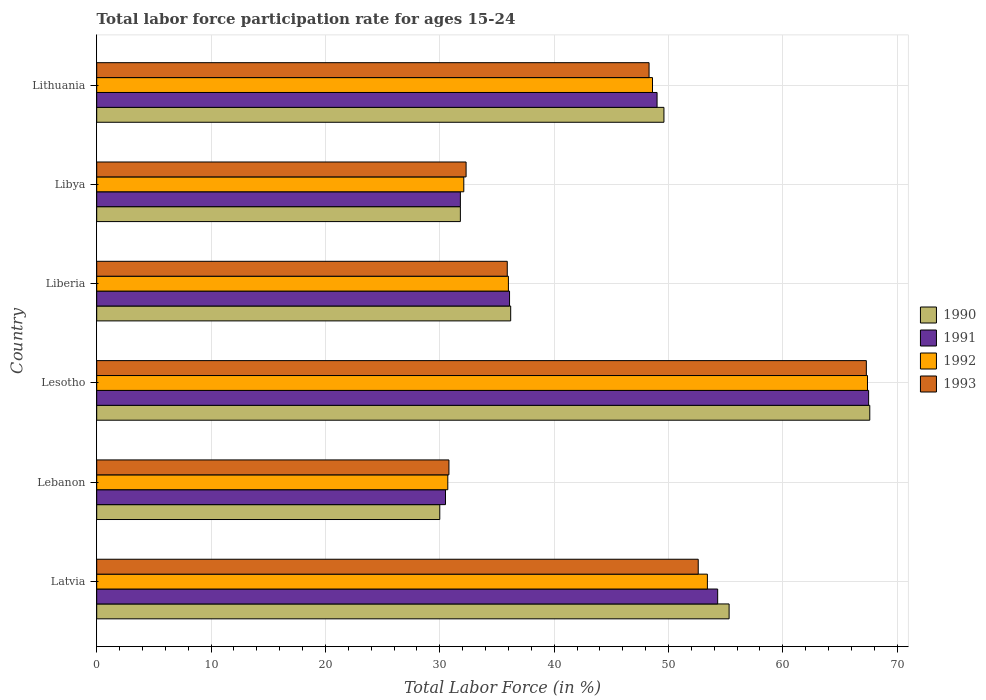How many different coloured bars are there?
Your answer should be compact. 4. How many groups of bars are there?
Ensure brevity in your answer.  6. Are the number of bars per tick equal to the number of legend labels?
Ensure brevity in your answer.  Yes. How many bars are there on the 3rd tick from the top?
Offer a terse response. 4. How many bars are there on the 6th tick from the bottom?
Your answer should be very brief. 4. What is the label of the 2nd group of bars from the top?
Ensure brevity in your answer.  Libya. What is the labor force participation rate in 1990 in Liberia?
Provide a succinct answer. 36.2. Across all countries, what is the maximum labor force participation rate in 1993?
Provide a short and direct response. 67.3. Across all countries, what is the minimum labor force participation rate in 1990?
Provide a short and direct response. 30. In which country was the labor force participation rate in 1991 maximum?
Make the answer very short. Lesotho. In which country was the labor force participation rate in 1990 minimum?
Your answer should be very brief. Lebanon. What is the total labor force participation rate in 1992 in the graph?
Provide a short and direct response. 268.2. What is the difference between the labor force participation rate in 1993 in Lebanon and that in Lesotho?
Ensure brevity in your answer.  -36.5. What is the difference between the labor force participation rate in 1992 in Lesotho and the labor force participation rate in 1993 in Lithuania?
Provide a succinct answer. 19.1. What is the average labor force participation rate in 1990 per country?
Your answer should be compact. 45.08. What is the difference between the labor force participation rate in 1991 and labor force participation rate in 1992 in Lebanon?
Your response must be concise. -0.2. In how many countries, is the labor force participation rate in 1990 greater than 68 %?
Keep it short and to the point. 0. What is the ratio of the labor force participation rate in 1992 in Latvia to that in Liberia?
Your answer should be compact. 1.48. Is the labor force participation rate in 1993 in Latvia less than that in Lebanon?
Your answer should be compact. No. Is the difference between the labor force participation rate in 1991 in Latvia and Liberia greater than the difference between the labor force participation rate in 1992 in Latvia and Liberia?
Your answer should be very brief. Yes. What is the difference between the highest and the second highest labor force participation rate in 1992?
Offer a terse response. 14. What is the difference between the highest and the lowest labor force participation rate in 1990?
Provide a short and direct response. 37.6. Is the sum of the labor force participation rate in 1992 in Latvia and Libya greater than the maximum labor force participation rate in 1990 across all countries?
Ensure brevity in your answer.  Yes. Is it the case that in every country, the sum of the labor force participation rate in 1992 and labor force participation rate in 1991 is greater than the sum of labor force participation rate in 1993 and labor force participation rate in 1990?
Your response must be concise. No. What does the 4th bar from the top in Latvia represents?
Your response must be concise. 1990. What does the 2nd bar from the bottom in Libya represents?
Keep it short and to the point. 1991. Are all the bars in the graph horizontal?
Provide a short and direct response. Yes. What is the difference between two consecutive major ticks on the X-axis?
Your answer should be compact. 10. Are the values on the major ticks of X-axis written in scientific E-notation?
Ensure brevity in your answer.  No. How many legend labels are there?
Ensure brevity in your answer.  4. What is the title of the graph?
Provide a short and direct response. Total labor force participation rate for ages 15-24. Does "1979" appear as one of the legend labels in the graph?
Your answer should be very brief. No. What is the label or title of the Y-axis?
Your response must be concise. Country. What is the Total Labor Force (in %) in 1990 in Latvia?
Offer a terse response. 55.3. What is the Total Labor Force (in %) of 1991 in Latvia?
Your answer should be very brief. 54.3. What is the Total Labor Force (in %) in 1992 in Latvia?
Offer a very short reply. 53.4. What is the Total Labor Force (in %) of 1993 in Latvia?
Your response must be concise. 52.6. What is the Total Labor Force (in %) of 1991 in Lebanon?
Offer a very short reply. 30.5. What is the Total Labor Force (in %) of 1992 in Lebanon?
Offer a terse response. 30.7. What is the Total Labor Force (in %) in 1993 in Lebanon?
Keep it short and to the point. 30.8. What is the Total Labor Force (in %) in 1990 in Lesotho?
Keep it short and to the point. 67.6. What is the Total Labor Force (in %) in 1991 in Lesotho?
Offer a very short reply. 67.5. What is the Total Labor Force (in %) in 1992 in Lesotho?
Make the answer very short. 67.4. What is the Total Labor Force (in %) of 1993 in Lesotho?
Your answer should be compact. 67.3. What is the Total Labor Force (in %) in 1990 in Liberia?
Your answer should be compact. 36.2. What is the Total Labor Force (in %) in 1991 in Liberia?
Give a very brief answer. 36.1. What is the Total Labor Force (in %) of 1992 in Liberia?
Offer a very short reply. 36. What is the Total Labor Force (in %) of 1993 in Liberia?
Give a very brief answer. 35.9. What is the Total Labor Force (in %) in 1990 in Libya?
Offer a very short reply. 31.8. What is the Total Labor Force (in %) in 1991 in Libya?
Provide a succinct answer. 31.8. What is the Total Labor Force (in %) of 1992 in Libya?
Your answer should be very brief. 32.1. What is the Total Labor Force (in %) in 1993 in Libya?
Offer a very short reply. 32.3. What is the Total Labor Force (in %) in 1990 in Lithuania?
Make the answer very short. 49.6. What is the Total Labor Force (in %) in 1991 in Lithuania?
Provide a short and direct response. 49. What is the Total Labor Force (in %) in 1992 in Lithuania?
Your answer should be very brief. 48.6. What is the Total Labor Force (in %) of 1993 in Lithuania?
Your answer should be very brief. 48.3. Across all countries, what is the maximum Total Labor Force (in %) in 1990?
Provide a succinct answer. 67.6. Across all countries, what is the maximum Total Labor Force (in %) of 1991?
Your answer should be very brief. 67.5. Across all countries, what is the maximum Total Labor Force (in %) in 1992?
Ensure brevity in your answer.  67.4. Across all countries, what is the maximum Total Labor Force (in %) of 1993?
Offer a very short reply. 67.3. Across all countries, what is the minimum Total Labor Force (in %) in 1991?
Provide a short and direct response. 30.5. Across all countries, what is the minimum Total Labor Force (in %) in 1992?
Provide a succinct answer. 30.7. Across all countries, what is the minimum Total Labor Force (in %) in 1993?
Provide a succinct answer. 30.8. What is the total Total Labor Force (in %) of 1990 in the graph?
Offer a very short reply. 270.5. What is the total Total Labor Force (in %) of 1991 in the graph?
Keep it short and to the point. 269.2. What is the total Total Labor Force (in %) in 1992 in the graph?
Your response must be concise. 268.2. What is the total Total Labor Force (in %) of 1993 in the graph?
Ensure brevity in your answer.  267.2. What is the difference between the Total Labor Force (in %) of 1990 in Latvia and that in Lebanon?
Provide a short and direct response. 25.3. What is the difference between the Total Labor Force (in %) in 1991 in Latvia and that in Lebanon?
Give a very brief answer. 23.8. What is the difference between the Total Labor Force (in %) of 1992 in Latvia and that in Lebanon?
Provide a short and direct response. 22.7. What is the difference between the Total Labor Force (in %) in 1993 in Latvia and that in Lebanon?
Provide a short and direct response. 21.8. What is the difference between the Total Labor Force (in %) in 1990 in Latvia and that in Lesotho?
Your answer should be compact. -12.3. What is the difference between the Total Labor Force (in %) in 1992 in Latvia and that in Lesotho?
Make the answer very short. -14. What is the difference between the Total Labor Force (in %) of 1993 in Latvia and that in Lesotho?
Your response must be concise. -14.7. What is the difference between the Total Labor Force (in %) of 1992 in Latvia and that in Liberia?
Offer a very short reply. 17.4. What is the difference between the Total Labor Force (in %) in 1993 in Latvia and that in Liberia?
Provide a succinct answer. 16.7. What is the difference between the Total Labor Force (in %) in 1990 in Latvia and that in Libya?
Keep it short and to the point. 23.5. What is the difference between the Total Labor Force (in %) in 1992 in Latvia and that in Libya?
Keep it short and to the point. 21.3. What is the difference between the Total Labor Force (in %) in 1993 in Latvia and that in Libya?
Keep it short and to the point. 20.3. What is the difference between the Total Labor Force (in %) in 1993 in Latvia and that in Lithuania?
Your answer should be very brief. 4.3. What is the difference between the Total Labor Force (in %) of 1990 in Lebanon and that in Lesotho?
Offer a very short reply. -37.6. What is the difference between the Total Labor Force (in %) of 1991 in Lebanon and that in Lesotho?
Keep it short and to the point. -37. What is the difference between the Total Labor Force (in %) of 1992 in Lebanon and that in Lesotho?
Your answer should be very brief. -36.7. What is the difference between the Total Labor Force (in %) of 1993 in Lebanon and that in Lesotho?
Provide a succinct answer. -36.5. What is the difference between the Total Labor Force (in %) of 1990 in Lebanon and that in Liberia?
Offer a terse response. -6.2. What is the difference between the Total Labor Force (in %) of 1993 in Lebanon and that in Liberia?
Your response must be concise. -5.1. What is the difference between the Total Labor Force (in %) of 1992 in Lebanon and that in Libya?
Provide a short and direct response. -1.4. What is the difference between the Total Labor Force (in %) of 1993 in Lebanon and that in Libya?
Your answer should be very brief. -1.5. What is the difference between the Total Labor Force (in %) in 1990 in Lebanon and that in Lithuania?
Offer a terse response. -19.6. What is the difference between the Total Labor Force (in %) of 1991 in Lebanon and that in Lithuania?
Give a very brief answer. -18.5. What is the difference between the Total Labor Force (in %) of 1992 in Lebanon and that in Lithuania?
Your answer should be very brief. -17.9. What is the difference between the Total Labor Force (in %) in 1993 in Lebanon and that in Lithuania?
Provide a succinct answer. -17.5. What is the difference between the Total Labor Force (in %) of 1990 in Lesotho and that in Liberia?
Your answer should be compact. 31.4. What is the difference between the Total Labor Force (in %) in 1991 in Lesotho and that in Liberia?
Your response must be concise. 31.4. What is the difference between the Total Labor Force (in %) of 1992 in Lesotho and that in Liberia?
Ensure brevity in your answer.  31.4. What is the difference between the Total Labor Force (in %) in 1993 in Lesotho and that in Liberia?
Provide a succinct answer. 31.4. What is the difference between the Total Labor Force (in %) of 1990 in Lesotho and that in Libya?
Your response must be concise. 35.8. What is the difference between the Total Labor Force (in %) of 1991 in Lesotho and that in Libya?
Your answer should be very brief. 35.7. What is the difference between the Total Labor Force (in %) of 1992 in Lesotho and that in Libya?
Give a very brief answer. 35.3. What is the difference between the Total Labor Force (in %) in 1990 in Lesotho and that in Lithuania?
Offer a very short reply. 18. What is the difference between the Total Labor Force (in %) of 1993 in Lesotho and that in Lithuania?
Your response must be concise. 19. What is the difference between the Total Labor Force (in %) of 1991 in Liberia and that in Libya?
Your answer should be very brief. 4.3. What is the difference between the Total Labor Force (in %) of 1992 in Liberia and that in Libya?
Offer a very short reply. 3.9. What is the difference between the Total Labor Force (in %) of 1990 in Liberia and that in Lithuania?
Your answer should be very brief. -13.4. What is the difference between the Total Labor Force (in %) in 1992 in Liberia and that in Lithuania?
Provide a succinct answer. -12.6. What is the difference between the Total Labor Force (in %) of 1993 in Liberia and that in Lithuania?
Your response must be concise. -12.4. What is the difference between the Total Labor Force (in %) in 1990 in Libya and that in Lithuania?
Provide a succinct answer. -17.8. What is the difference between the Total Labor Force (in %) in 1991 in Libya and that in Lithuania?
Your answer should be very brief. -17.2. What is the difference between the Total Labor Force (in %) in 1992 in Libya and that in Lithuania?
Ensure brevity in your answer.  -16.5. What is the difference between the Total Labor Force (in %) of 1993 in Libya and that in Lithuania?
Make the answer very short. -16. What is the difference between the Total Labor Force (in %) in 1990 in Latvia and the Total Labor Force (in %) in 1991 in Lebanon?
Make the answer very short. 24.8. What is the difference between the Total Labor Force (in %) in 1990 in Latvia and the Total Labor Force (in %) in 1992 in Lebanon?
Provide a short and direct response. 24.6. What is the difference between the Total Labor Force (in %) of 1990 in Latvia and the Total Labor Force (in %) of 1993 in Lebanon?
Your response must be concise. 24.5. What is the difference between the Total Labor Force (in %) of 1991 in Latvia and the Total Labor Force (in %) of 1992 in Lebanon?
Keep it short and to the point. 23.6. What is the difference between the Total Labor Force (in %) in 1991 in Latvia and the Total Labor Force (in %) in 1993 in Lebanon?
Make the answer very short. 23.5. What is the difference between the Total Labor Force (in %) of 1992 in Latvia and the Total Labor Force (in %) of 1993 in Lebanon?
Give a very brief answer. 22.6. What is the difference between the Total Labor Force (in %) in 1990 in Latvia and the Total Labor Force (in %) in 1991 in Lesotho?
Give a very brief answer. -12.2. What is the difference between the Total Labor Force (in %) in 1990 in Latvia and the Total Labor Force (in %) in 1991 in Liberia?
Provide a short and direct response. 19.2. What is the difference between the Total Labor Force (in %) in 1990 in Latvia and the Total Labor Force (in %) in 1992 in Liberia?
Provide a short and direct response. 19.3. What is the difference between the Total Labor Force (in %) of 1990 in Latvia and the Total Labor Force (in %) of 1993 in Liberia?
Offer a terse response. 19.4. What is the difference between the Total Labor Force (in %) of 1990 in Latvia and the Total Labor Force (in %) of 1992 in Libya?
Provide a short and direct response. 23.2. What is the difference between the Total Labor Force (in %) in 1991 in Latvia and the Total Labor Force (in %) in 1993 in Libya?
Offer a very short reply. 22. What is the difference between the Total Labor Force (in %) in 1992 in Latvia and the Total Labor Force (in %) in 1993 in Libya?
Give a very brief answer. 21.1. What is the difference between the Total Labor Force (in %) of 1990 in Latvia and the Total Labor Force (in %) of 1993 in Lithuania?
Provide a short and direct response. 7. What is the difference between the Total Labor Force (in %) in 1991 in Latvia and the Total Labor Force (in %) in 1992 in Lithuania?
Offer a very short reply. 5.7. What is the difference between the Total Labor Force (in %) of 1991 in Latvia and the Total Labor Force (in %) of 1993 in Lithuania?
Give a very brief answer. 6. What is the difference between the Total Labor Force (in %) in 1990 in Lebanon and the Total Labor Force (in %) in 1991 in Lesotho?
Provide a succinct answer. -37.5. What is the difference between the Total Labor Force (in %) of 1990 in Lebanon and the Total Labor Force (in %) of 1992 in Lesotho?
Your response must be concise. -37.4. What is the difference between the Total Labor Force (in %) of 1990 in Lebanon and the Total Labor Force (in %) of 1993 in Lesotho?
Offer a very short reply. -37.3. What is the difference between the Total Labor Force (in %) of 1991 in Lebanon and the Total Labor Force (in %) of 1992 in Lesotho?
Offer a very short reply. -36.9. What is the difference between the Total Labor Force (in %) in 1991 in Lebanon and the Total Labor Force (in %) in 1993 in Lesotho?
Make the answer very short. -36.8. What is the difference between the Total Labor Force (in %) of 1992 in Lebanon and the Total Labor Force (in %) of 1993 in Lesotho?
Provide a succinct answer. -36.6. What is the difference between the Total Labor Force (in %) of 1990 in Lebanon and the Total Labor Force (in %) of 1991 in Liberia?
Your answer should be very brief. -6.1. What is the difference between the Total Labor Force (in %) in 1990 in Lebanon and the Total Labor Force (in %) in 1992 in Liberia?
Offer a very short reply. -6. What is the difference between the Total Labor Force (in %) in 1990 in Lebanon and the Total Labor Force (in %) in 1993 in Liberia?
Provide a succinct answer. -5.9. What is the difference between the Total Labor Force (in %) of 1991 in Lebanon and the Total Labor Force (in %) of 1992 in Liberia?
Your answer should be very brief. -5.5. What is the difference between the Total Labor Force (in %) in 1991 in Lebanon and the Total Labor Force (in %) in 1993 in Liberia?
Your answer should be compact. -5.4. What is the difference between the Total Labor Force (in %) in 1992 in Lebanon and the Total Labor Force (in %) in 1993 in Liberia?
Offer a very short reply. -5.2. What is the difference between the Total Labor Force (in %) of 1990 in Lebanon and the Total Labor Force (in %) of 1992 in Libya?
Give a very brief answer. -2.1. What is the difference between the Total Labor Force (in %) of 1990 in Lebanon and the Total Labor Force (in %) of 1993 in Libya?
Offer a very short reply. -2.3. What is the difference between the Total Labor Force (in %) of 1991 in Lebanon and the Total Labor Force (in %) of 1993 in Libya?
Offer a very short reply. -1.8. What is the difference between the Total Labor Force (in %) of 1990 in Lebanon and the Total Labor Force (in %) of 1991 in Lithuania?
Provide a short and direct response. -19. What is the difference between the Total Labor Force (in %) in 1990 in Lebanon and the Total Labor Force (in %) in 1992 in Lithuania?
Offer a terse response. -18.6. What is the difference between the Total Labor Force (in %) of 1990 in Lebanon and the Total Labor Force (in %) of 1993 in Lithuania?
Your answer should be compact. -18.3. What is the difference between the Total Labor Force (in %) of 1991 in Lebanon and the Total Labor Force (in %) of 1992 in Lithuania?
Offer a terse response. -18.1. What is the difference between the Total Labor Force (in %) in 1991 in Lebanon and the Total Labor Force (in %) in 1993 in Lithuania?
Offer a terse response. -17.8. What is the difference between the Total Labor Force (in %) in 1992 in Lebanon and the Total Labor Force (in %) in 1993 in Lithuania?
Provide a succinct answer. -17.6. What is the difference between the Total Labor Force (in %) of 1990 in Lesotho and the Total Labor Force (in %) of 1991 in Liberia?
Ensure brevity in your answer.  31.5. What is the difference between the Total Labor Force (in %) in 1990 in Lesotho and the Total Labor Force (in %) in 1992 in Liberia?
Provide a succinct answer. 31.6. What is the difference between the Total Labor Force (in %) in 1990 in Lesotho and the Total Labor Force (in %) in 1993 in Liberia?
Your answer should be very brief. 31.7. What is the difference between the Total Labor Force (in %) of 1991 in Lesotho and the Total Labor Force (in %) of 1992 in Liberia?
Make the answer very short. 31.5. What is the difference between the Total Labor Force (in %) of 1991 in Lesotho and the Total Labor Force (in %) of 1993 in Liberia?
Keep it short and to the point. 31.6. What is the difference between the Total Labor Force (in %) in 1992 in Lesotho and the Total Labor Force (in %) in 1993 in Liberia?
Your response must be concise. 31.5. What is the difference between the Total Labor Force (in %) in 1990 in Lesotho and the Total Labor Force (in %) in 1991 in Libya?
Your answer should be very brief. 35.8. What is the difference between the Total Labor Force (in %) of 1990 in Lesotho and the Total Labor Force (in %) of 1992 in Libya?
Your answer should be compact. 35.5. What is the difference between the Total Labor Force (in %) of 1990 in Lesotho and the Total Labor Force (in %) of 1993 in Libya?
Offer a very short reply. 35.3. What is the difference between the Total Labor Force (in %) of 1991 in Lesotho and the Total Labor Force (in %) of 1992 in Libya?
Offer a very short reply. 35.4. What is the difference between the Total Labor Force (in %) in 1991 in Lesotho and the Total Labor Force (in %) in 1993 in Libya?
Offer a terse response. 35.2. What is the difference between the Total Labor Force (in %) in 1992 in Lesotho and the Total Labor Force (in %) in 1993 in Libya?
Offer a very short reply. 35.1. What is the difference between the Total Labor Force (in %) of 1990 in Lesotho and the Total Labor Force (in %) of 1993 in Lithuania?
Make the answer very short. 19.3. What is the difference between the Total Labor Force (in %) in 1992 in Lesotho and the Total Labor Force (in %) in 1993 in Lithuania?
Make the answer very short. 19.1. What is the difference between the Total Labor Force (in %) in 1990 in Liberia and the Total Labor Force (in %) in 1993 in Libya?
Your answer should be very brief. 3.9. What is the difference between the Total Labor Force (in %) of 1991 in Liberia and the Total Labor Force (in %) of 1993 in Libya?
Keep it short and to the point. 3.8. What is the difference between the Total Labor Force (in %) in 1992 in Liberia and the Total Labor Force (in %) in 1993 in Libya?
Your answer should be very brief. 3.7. What is the difference between the Total Labor Force (in %) of 1990 in Liberia and the Total Labor Force (in %) of 1991 in Lithuania?
Keep it short and to the point. -12.8. What is the difference between the Total Labor Force (in %) in 1990 in Liberia and the Total Labor Force (in %) in 1992 in Lithuania?
Offer a terse response. -12.4. What is the difference between the Total Labor Force (in %) of 1990 in Libya and the Total Labor Force (in %) of 1991 in Lithuania?
Offer a terse response. -17.2. What is the difference between the Total Labor Force (in %) of 1990 in Libya and the Total Labor Force (in %) of 1992 in Lithuania?
Provide a succinct answer. -16.8. What is the difference between the Total Labor Force (in %) of 1990 in Libya and the Total Labor Force (in %) of 1993 in Lithuania?
Keep it short and to the point. -16.5. What is the difference between the Total Labor Force (in %) in 1991 in Libya and the Total Labor Force (in %) in 1992 in Lithuania?
Your response must be concise. -16.8. What is the difference between the Total Labor Force (in %) in 1991 in Libya and the Total Labor Force (in %) in 1993 in Lithuania?
Ensure brevity in your answer.  -16.5. What is the difference between the Total Labor Force (in %) of 1992 in Libya and the Total Labor Force (in %) of 1993 in Lithuania?
Provide a succinct answer. -16.2. What is the average Total Labor Force (in %) in 1990 per country?
Your answer should be very brief. 45.08. What is the average Total Labor Force (in %) in 1991 per country?
Keep it short and to the point. 44.87. What is the average Total Labor Force (in %) in 1992 per country?
Keep it short and to the point. 44.7. What is the average Total Labor Force (in %) of 1993 per country?
Your response must be concise. 44.53. What is the difference between the Total Labor Force (in %) in 1990 and Total Labor Force (in %) in 1991 in Latvia?
Offer a terse response. 1. What is the difference between the Total Labor Force (in %) in 1990 and Total Labor Force (in %) in 1993 in Latvia?
Ensure brevity in your answer.  2.7. What is the difference between the Total Labor Force (in %) of 1992 and Total Labor Force (in %) of 1993 in Latvia?
Offer a very short reply. 0.8. What is the difference between the Total Labor Force (in %) of 1991 and Total Labor Force (in %) of 1992 in Lebanon?
Offer a terse response. -0.2. What is the difference between the Total Labor Force (in %) of 1991 and Total Labor Force (in %) of 1993 in Lebanon?
Your answer should be very brief. -0.3. What is the difference between the Total Labor Force (in %) of 1990 and Total Labor Force (in %) of 1991 in Lesotho?
Give a very brief answer. 0.1. What is the difference between the Total Labor Force (in %) of 1990 and Total Labor Force (in %) of 1992 in Lesotho?
Your answer should be very brief. 0.2. What is the difference between the Total Labor Force (in %) of 1990 and Total Labor Force (in %) of 1993 in Lesotho?
Offer a terse response. 0.3. What is the difference between the Total Labor Force (in %) of 1991 and Total Labor Force (in %) of 1992 in Lesotho?
Give a very brief answer. 0.1. What is the difference between the Total Labor Force (in %) of 1992 and Total Labor Force (in %) of 1993 in Lesotho?
Your answer should be compact. 0.1. What is the difference between the Total Labor Force (in %) in 1990 and Total Labor Force (in %) in 1991 in Liberia?
Provide a succinct answer. 0.1. What is the difference between the Total Labor Force (in %) in 1990 and Total Labor Force (in %) in 1993 in Liberia?
Ensure brevity in your answer.  0.3. What is the difference between the Total Labor Force (in %) in 1991 and Total Labor Force (in %) in 1993 in Liberia?
Ensure brevity in your answer.  0.2. What is the difference between the Total Labor Force (in %) of 1991 and Total Labor Force (in %) of 1992 in Libya?
Provide a short and direct response. -0.3. What is the difference between the Total Labor Force (in %) of 1991 and Total Labor Force (in %) of 1993 in Lithuania?
Provide a short and direct response. 0.7. What is the difference between the Total Labor Force (in %) in 1992 and Total Labor Force (in %) in 1993 in Lithuania?
Your answer should be very brief. 0.3. What is the ratio of the Total Labor Force (in %) in 1990 in Latvia to that in Lebanon?
Your response must be concise. 1.84. What is the ratio of the Total Labor Force (in %) of 1991 in Latvia to that in Lebanon?
Make the answer very short. 1.78. What is the ratio of the Total Labor Force (in %) in 1992 in Latvia to that in Lebanon?
Make the answer very short. 1.74. What is the ratio of the Total Labor Force (in %) in 1993 in Latvia to that in Lebanon?
Keep it short and to the point. 1.71. What is the ratio of the Total Labor Force (in %) of 1990 in Latvia to that in Lesotho?
Your response must be concise. 0.82. What is the ratio of the Total Labor Force (in %) in 1991 in Latvia to that in Lesotho?
Keep it short and to the point. 0.8. What is the ratio of the Total Labor Force (in %) of 1992 in Latvia to that in Lesotho?
Your answer should be compact. 0.79. What is the ratio of the Total Labor Force (in %) in 1993 in Latvia to that in Lesotho?
Your answer should be compact. 0.78. What is the ratio of the Total Labor Force (in %) of 1990 in Latvia to that in Liberia?
Your response must be concise. 1.53. What is the ratio of the Total Labor Force (in %) in 1991 in Latvia to that in Liberia?
Provide a succinct answer. 1.5. What is the ratio of the Total Labor Force (in %) of 1992 in Latvia to that in Liberia?
Keep it short and to the point. 1.48. What is the ratio of the Total Labor Force (in %) in 1993 in Latvia to that in Liberia?
Make the answer very short. 1.47. What is the ratio of the Total Labor Force (in %) in 1990 in Latvia to that in Libya?
Provide a short and direct response. 1.74. What is the ratio of the Total Labor Force (in %) in 1991 in Latvia to that in Libya?
Provide a succinct answer. 1.71. What is the ratio of the Total Labor Force (in %) of 1992 in Latvia to that in Libya?
Offer a very short reply. 1.66. What is the ratio of the Total Labor Force (in %) of 1993 in Latvia to that in Libya?
Your answer should be compact. 1.63. What is the ratio of the Total Labor Force (in %) of 1990 in Latvia to that in Lithuania?
Your answer should be compact. 1.11. What is the ratio of the Total Labor Force (in %) in 1991 in Latvia to that in Lithuania?
Make the answer very short. 1.11. What is the ratio of the Total Labor Force (in %) in 1992 in Latvia to that in Lithuania?
Give a very brief answer. 1.1. What is the ratio of the Total Labor Force (in %) in 1993 in Latvia to that in Lithuania?
Offer a very short reply. 1.09. What is the ratio of the Total Labor Force (in %) of 1990 in Lebanon to that in Lesotho?
Your answer should be compact. 0.44. What is the ratio of the Total Labor Force (in %) of 1991 in Lebanon to that in Lesotho?
Provide a succinct answer. 0.45. What is the ratio of the Total Labor Force (in %) of 1992 in Lebanon to that in Lesotho?
Offer a terse response. 0.46. What is the ratio of the Total Labor Force (in %) in 1993 in Lebanon to that in Lesotho?
Make the answer very short. 0.46. What is the ratio of the Total Labor Force (in %) of 1990 in Lebanon to that in Liberia?
Your answer should be compact. 0.83. What is the ratio of the Total Labor Force (in %) in 1991 in Lebanon to that in Liberia?
Keep it short and to the point. 0.84. What is the ratio of the Total Labor Force (in %) of 1992 in Lebanon to that in Liberia?
Ensure brevity in your answer.  0.85. What is the ratio of the Total Labor Force (in %) of 1993 in Lebanon to that in Liberia?
Offer a terse response. 0.86. What is the ratio of the Total Labor Force (in %) of 1990 in Lebanon to that in Libya?
Offer a very short reply. 0.94. What is the ratio of the Total Labor Force (in %) of 1991 in Lebanon to that in Libya?
Offer a very short reply. 0.96. What is the ratio of the Total Labor Force (in %) in 1992 in Lebanon to that in Libya?
Ensure brevity in your answer.  0.96. What is the ratio of the Total Labor Force (in %) in 1993 in Lebanon to that in Libya?
Give a very brief answer. 0.95. What is the ratio of the Total Labor Force (in %) of 1990 in Lebanon to that in Lithuania?
Provide a short and direct response. 0.6. What is the ratio of the Total Labor Force (in %) in 1991 in Lebanon to that in Lithuania?
Your response must be concise. 0.62. What is the ratio of the Total Labor Force (in %) of 1992 in Lebanon to that in Lithuania?
Your answer should be very brief. 0.63. What is the ratio of the Total Labor Force (in %) in 1993 in Lebanon to that in Lithuania?
Your response must be concise. 0.64. What is the ratio of the Total Labor Force (in %) of 1990 in Lesotho to that in Liberia?
Offer a very short reply. 1.87. What is the ratio of the Total Labor Force (in %) of 1991 in Lesotho to that in Liberia?
Give a very brief answer. 1.87. What is the ratio of the Total Labor Force (in %) of 1992 in Lesotho to that in Liberia?
Offer a very short reply. 1.87. What is the ratio of the Total Labor Force (in %) in 1993 in Lesotho to that in Liberia?
Offer a very short reply. 1.87. What is the ratio of the Total Labor Force (in %) of 1990 in Lesotho to that in Libya?
Your response must be concise. 2.13. What is the ratio of the Total Labor Force (in %) of 1991 in Lesotho to that in Libya?
Make the answer very short. 2.12. What is the ratio of the Total Labor Force (in %) in 1992 in Lesotho to that in Libya?
Give a very brief answer. 2.1. What is the ratio of the Total Labor Force (in %) of 1993 in Lesotho to that in Libya?
Offer a terse response. 2.08. What is the ratio of the Total Labor Force (in %) in 1990 in Lesotho to that in Lithuania?
Your answer should be compact. 1.36. What is the ratio of the Total Labor Force (in %) of 1991 in Lesotho to that in Lithuania?
Your answer should be very brief. 1.38. What is the ratio of the Total Labor Force (in %) in 1992 in Lesotho to that in Lithuania?
Keep it short and to the point. 1.39. What is the ratio of the Total Labor Force (in %) of 1993 in Lesotho to that in Lithuania?
Your response must be concise. 1.39. What is the ratio of the Total Labor Force (in %) in 1990 in Liberia to that in Libya?
Your answer should be very brief. 1.14. What is the ratio of the Total Labor Force (in %) in 1991 in Liberia to that in Libya?
Give a very brief answer. 1.14. What is the ratio of the Total Labor Force (in %) in 1992 in Liberia to that in Libya?
Keep it short and to the point. 1.12. What is the ratio of the Total Labor Force (in %) in 1993 in Liberia to that in Libya?
Your answer should be very brief. 1.11. What is the ratio of the Total Labor Force (in %) of 1990 in Liberia to that in Lithuania?
Your response must be concise. 0.73. What is the ratio of the Total Labor Force (in %) in 1991 in Liberia to that in Lithuania?
Provide a succinct answer. 0.74. What is the ratio of the Total Labor Force (in %) in 1992 in Liberia to that in Lithuania?
Offer a very short reply. 0.74. What is the ratio of the Total Labor Force (in %) of 1993 in Liberia to that in Lithuania?
Your answer should be compact. 0.74. What is the ratio of the Total Labor Force (in %) of 1990 in Libya to that in Lithuania?
Provide a short and direct response. 0.64. What is the ratio of the Total Labor Force (in %) in 1991 in Libya to that in Lithuania?
Make the answer very short. 0.65. What is the ratio of the Total Labor Force (in %) of 1992 in Libya to that in Lithuania?
Give a very brief answer. 0.66. What is the ratio of the Total Labor Force (in %) in 1993 in Libya to that in Lithuania?
Your response must be concise. 0.67. What is the difference between the highest and the second highest Total Labor Force (in %) in 1990?
Keep it short and to the point. 12.3. What is the difference between the highest and the second highest Total Labor Force (in %) of 1993?
Keep it short and to the point. 14.7. What is the difference between the highest and the lowest Total Labor Force (in %) of 1990?
Your response must be concise. 37.6. What is the difference between the highest and the lowest Total Labor Force (in %) in 1992?
Provide a succinct answer. 36.7. What is the difference between the highest and the lowest Total Labor Force (in %) in 1993?
Offer a terse response. 36.5. 